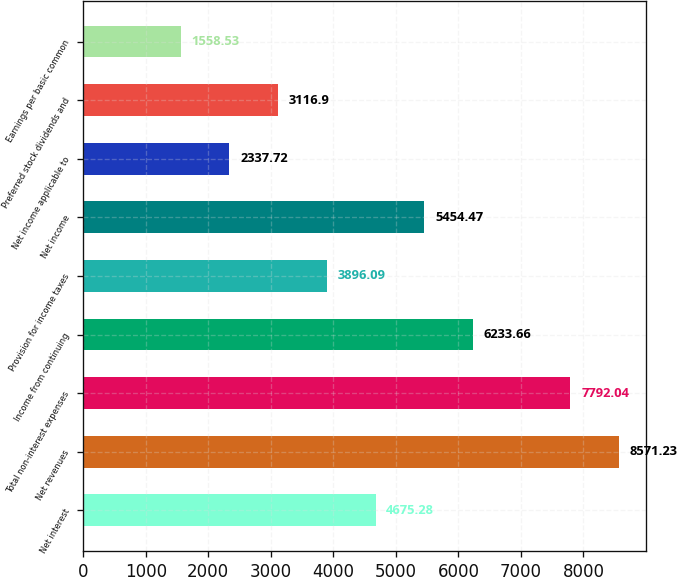Convert chart to OTSL. <chart><loc_0><loc_0><loc_500><loc_500><bar_chart><fcel>Net interest<fcel>Net revenues<fcel>Total non-interest expenses<fcel>Income from continuing<fcel>Provision for income taxes<fcel>Net income<fcel>Net income applicable to<fcel>Preferred stock dividends and<fcel>Earnings per basic common<nl><fcel>4675.28<fcel>8571.23<fcel>7792.04<fcel>6233.66<fcel>3896.09<fcel>5454.47<fcel>2337.72<fcel>3116.9<fcel>1558.53<nl></chart> 